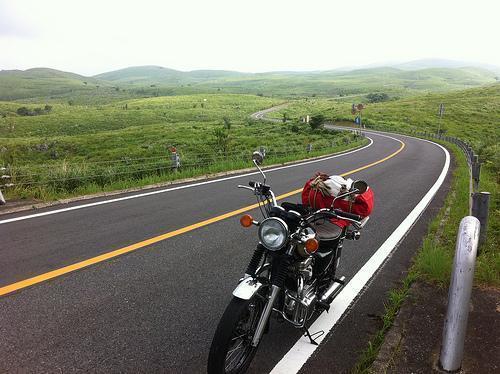How many motorcycles?
Give a very brief answer. 1. How many turn signals?
Give a very brief answer. 2. 